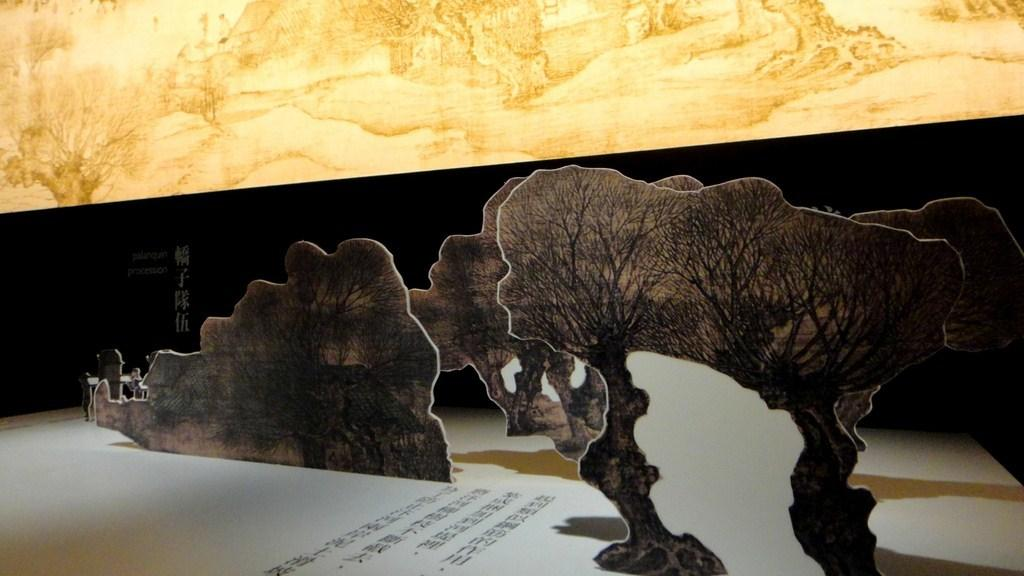What type of furniture is visible in the image? There is a table in the image. What is placed on the table? Papers are present on the table. What kind of decorative items can be seen in the image? There are paper trees in the image. How would you describe the color of the wall in the background? The wall in the background is white and cream colored. How many potatoes are stacked on the table in the image? There are no potatoes present in the image; it features a table with papers and paper trees. What type of zebra can be seen interacting with the paper trees in the image? There is no zebra present in the image; it only features a table, papers, and paper trees. 